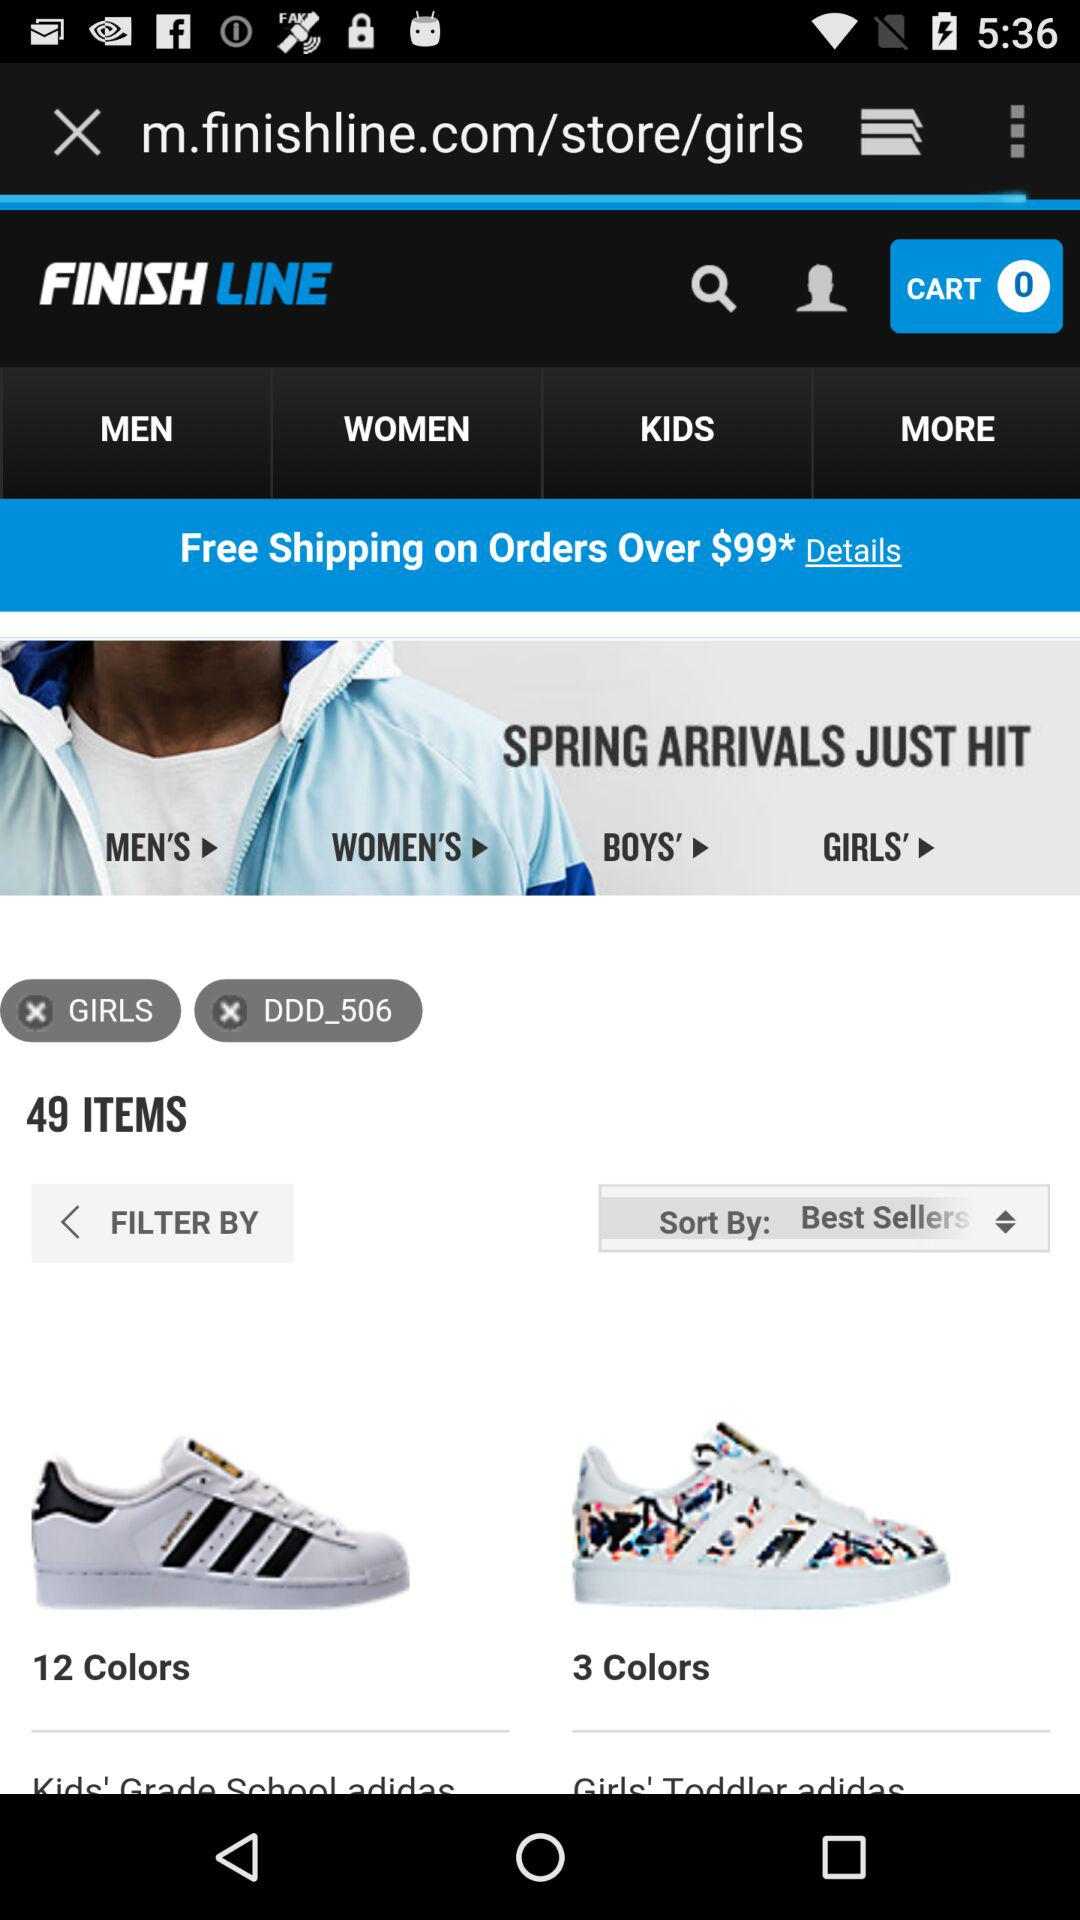How many more colors are available for the first item than the second item?
Answer the question using a single word or phrase. 9 